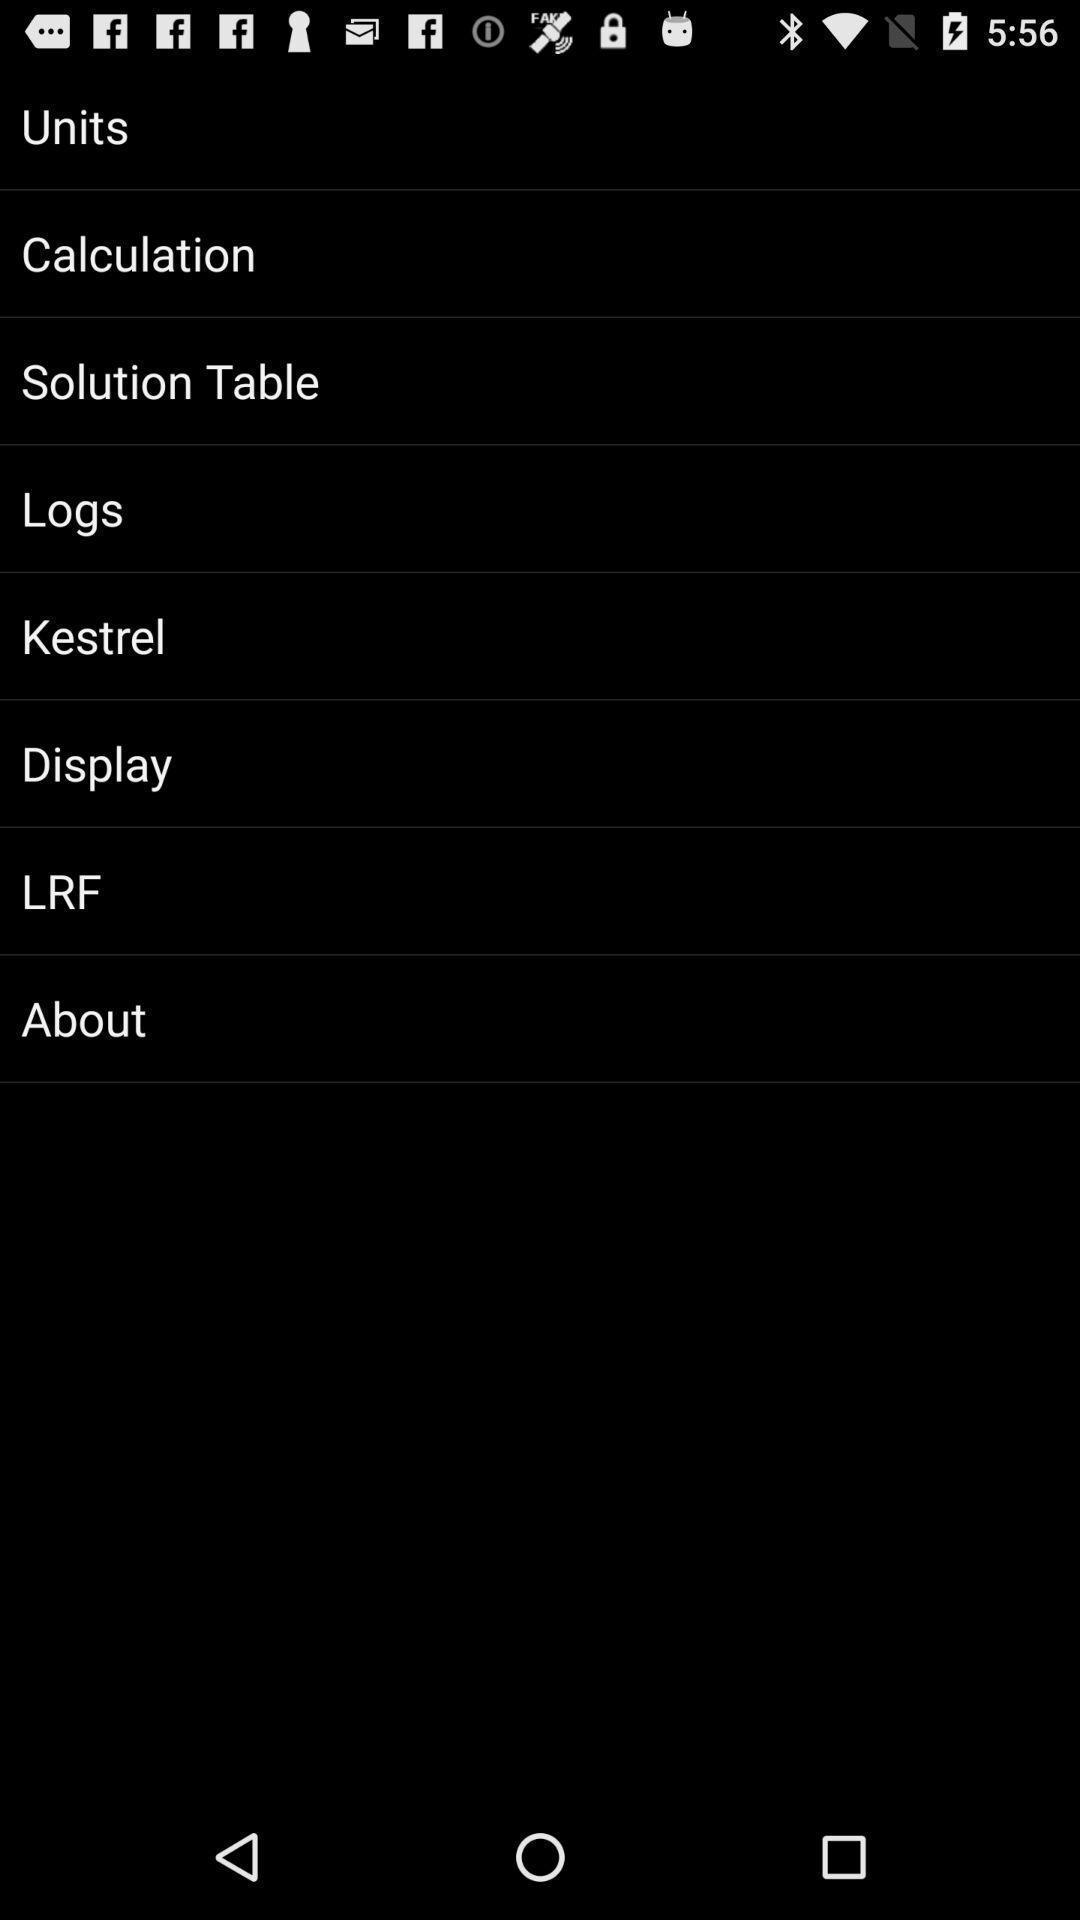Provide a textual representation of this image. Page showing different options on an app. 